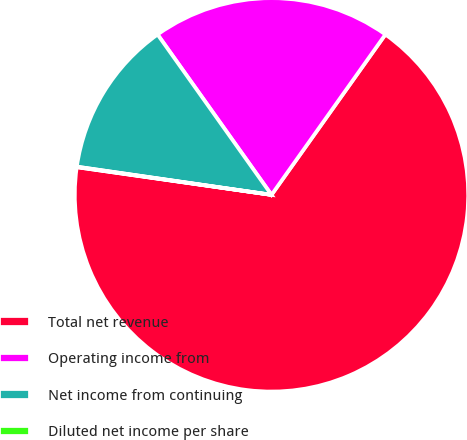<chart> <loc_0><loc_0><loc_500><loc_500><pie_chart><fcel>Total net revenue<fcel>Operating income from<fcel>Net income from continuing<fcel>Diluted net income per share<nl><fcel>67.42%<fcel>19.66%<fcel>12.88%<fcel>0.04%<nl></chart> 